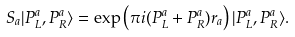<formula> <loc_0><loc_0><loc_500><loc_500>S _ { a } | P ^ { a } _ { L } , P ^ { a } _ { R } \rangle = \exp \left ( \pi i ( P ^ { a } _ { L } + P ^ { a } _ { R } ) r _ { a } \right ) | P ^ { a } _ { L } , P ^ { a } _ { R } \rangle .</formula> 